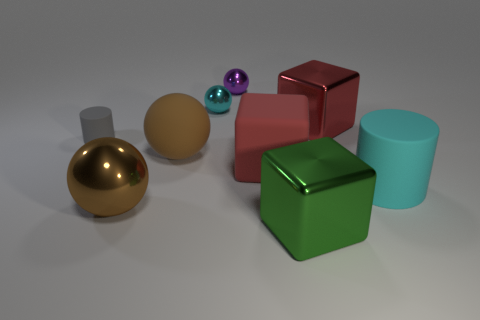If this image were part of a learning module, what concepts might it be used to teach? This image could be used in a learning module to teach concepts such as geometry, light and shadow, material properties, computer graphics, or even color theory, given the variety of shapes, textures, and colors present. 